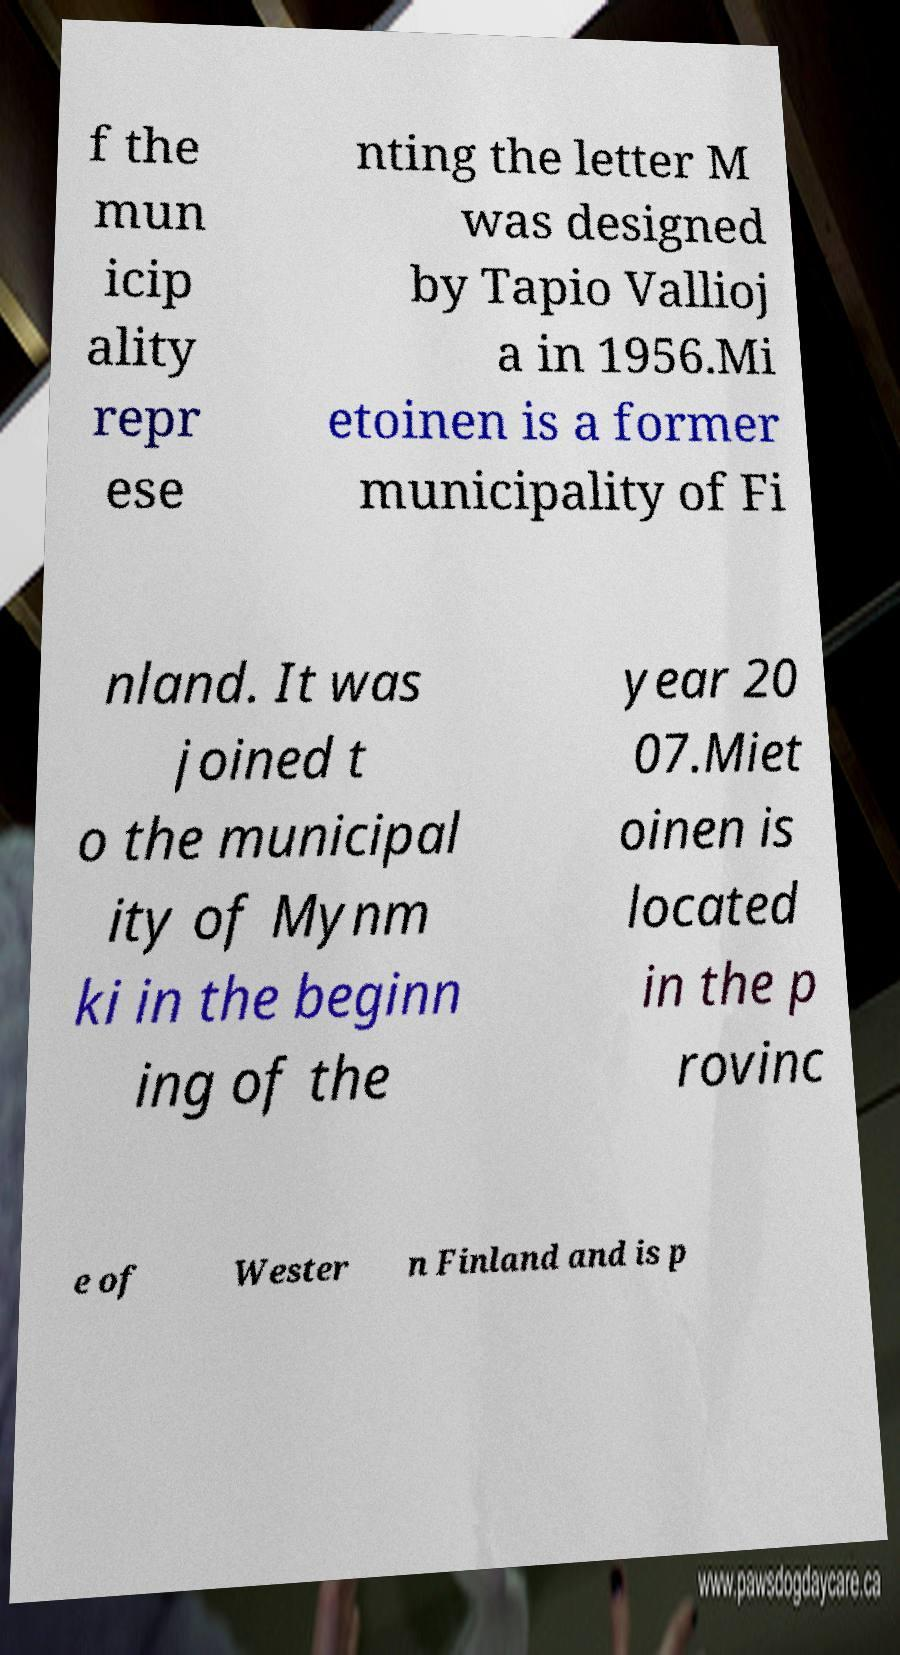What messages or text are displayed in this image? I need them in a readable, typed format. f the mun icip ality repr ese nting the letter M was designed by Tapio Vallioj a in 1956.Mi etoinen is a former municipality of Fi nland. It was joined t o the municipal ity of Mynm ki in the beginn ing of the year 20 07.Miet oinen is located in the p rovinc e of Wester n Finland and is p 